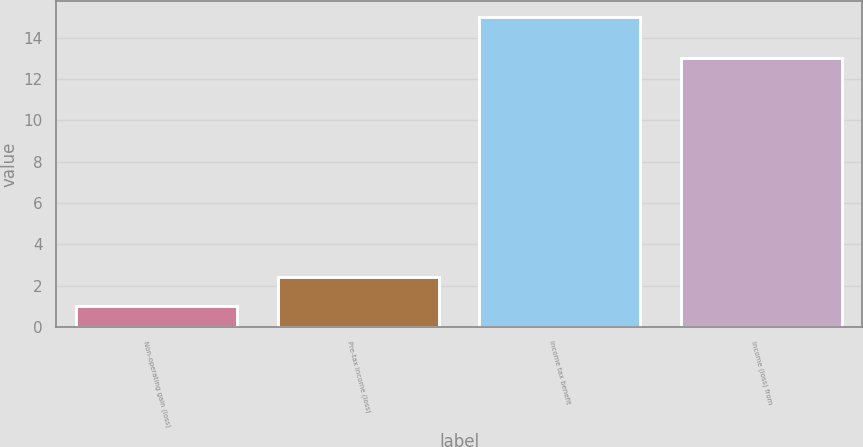Convert chart to OTSL. <chart><loc_0><loc_0><loc_500><loc_500><bar_chart><fcel>Non-operating gain (loss)<fcel>Pre-tax income (loss)<fcel>Income tax benefit<fcel>Income (loss) from<nl><fcel>1<fcel>2.4<fcel>15<fcel>13<nl></chart> 